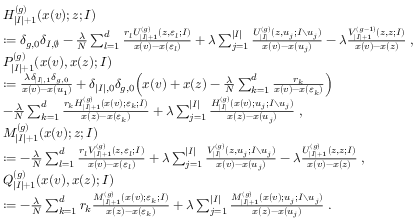Convert formula to latex. <formula><loc_0><loc_0><loc_500><loc_500>\begin{array} { r l } & { H _ { | I | + 1 } ^ { ( g ) } ( x ( v ) ; z ; I ) } \\ & { \colon = \delta _ { g , 0 } \delta _ { I , \emptyset } - \frac { \lambda } { N } \sum _ { l = 1 } ^ { d } \frac { r _ { l } U _ { | I | + 1 } ^ { ( g ) } ( z , \varepsilon _ { l } ; I ) } { x ( v ) - x ( \varepsilon _ { l } ) } + \lambda \sum _ { j = 1 } ^ { | I | } \frac { U _ { | I | } ^ { ( g ) } ( z , u _ { j } ; I { \ } u _ { j } ) } { x ( v ) - x ( u _ { j } ) } - \lambda \frac { V _ { | I | + 1 } ^ { ( g - 1 ) } ( z , z ; I ) } { x ( v ) - x ( z ) } \, , } \\ & { P _ { | I | + 1 } ^ { ( g ) } ( x ( v ) , x ( z ) ; I ) } \\ & { \colon = \frac { \lambda \delta _ { | I | , 1 } \delta _ { g , 0 } } { x ( v ) - x ( u _ { 1 } ) } + \delta _ { | I | , 0 } \delta _ { g , 0 } \left ( x ( v ) + x ( z ) - \frac { \lambda } { N } \sum _ { k = 1 } ^ { d } \frac { r _ { k } } { x ( v ) - x ( \varepsilon _ { k } ) } \right ) } \\ & { - \frac { \lambda } { N } \sum _ { k = 1 } ^ { d } \frac { r _ { k } H _ { | I | + 1 } ^ { ( g ) } ( x ( v ) ; \varepsilon _ { k } ; I ) } { x ( z ) - x ( \varepsilon _ { k } ) } + \lambda \sum _ { j = 1 } ^ { | I | } \frac { H _ { | I | } ^ { ( g ) } ( x ( v ) ; u _ { j } ; I \ u _ { j } ) } { x ( z ) - x ( u _ { j } ) } \, , } \\ & { M _ { | I | + 1 } ^ { ( g ) } ( x ( v ) ; z ; I ) } \\ & { \colon = - \frac { \lambda } { N } \sum _ { l = 1 } ^ { d } \frac { r _ { l } V _ { | I | + 1 } ^ { ( g ) } ( z , \varepsilon _ { l } ; I ) } { x ( v ) - x ( \varepsilon _ { l } ) } + \lambda \sum _ { j = 1 } ^ { | I | } \frac { V _ { | I | } ^ { ( g ) } ( z , u _ { j } ; I { \ } u _ { j } ) } { x ( v ) - x ( u _ { j } ) } - \lambda \frac { U _ { | I | + 1 } ^ { ( g ) } ( z , z ; I ) } { x ( v ) - x ( z ) } \, , } \\ & { Q _ { | I | + 1 } ^ { ( g ) } ( x ( v ) , x ( z ) ; I ) } \\ & { \colon = - \frac { \lambda } { N } \sum _ { k = 1 } ^ { d } r _ { k } \frac { M _ { | I | + 1 } ^ { ( g ) } ( x ( v ) ; \varepsilon _ { k } ; I ) } { x ( z ) - x ( \varepsilon _ { k } ) } + \lambda \sum _ { j = 1 } ^ { | I | } \frac { M _ { | I | + 1 } ^ { ( g ) } ( x ( v ) ; u _ { j } ; I { \ } u _ { j } ) } { x ( z ) - x ( u _ { j } ) } \, . } \end{array}</formula> 